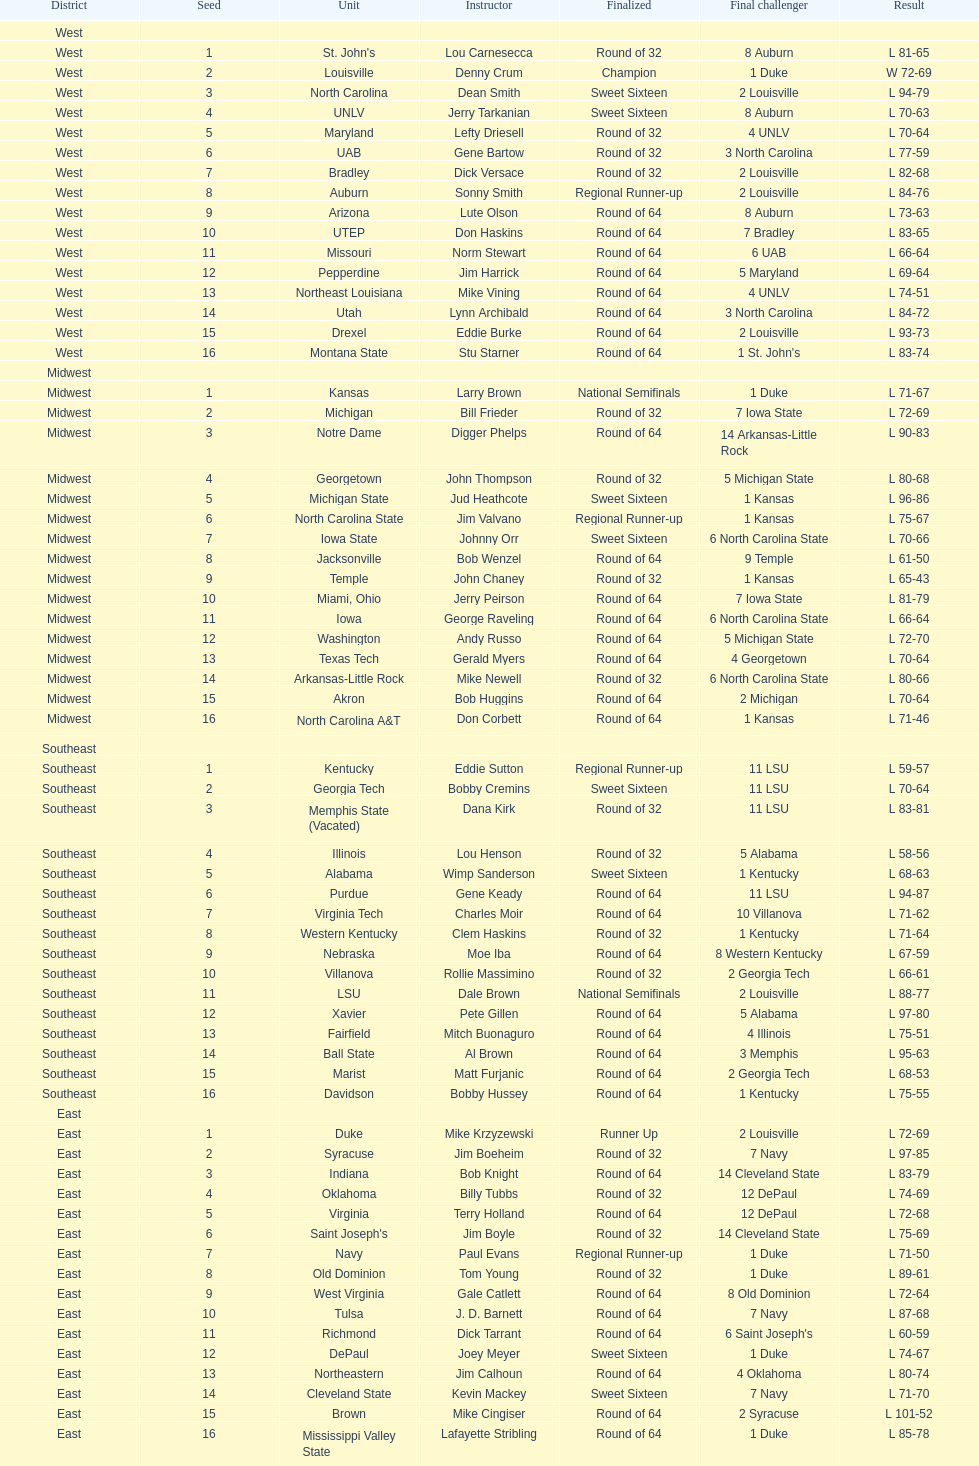What team finished at the top of all else and was finished as champions? Louisville. 